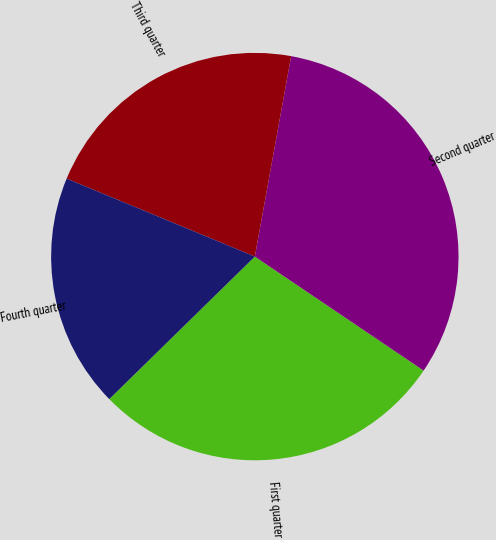Convert chart. <chart><loc_0><loc_0><loc_500><loc_500><pie_chart><fcel>First quarter<fcel>Second quarter<fcel>Third quarter<fcel>Fourth quarter<nl><fcel>28.21%<fcel>31.6%<fcel>21.6%<fcel>18.58%<nl></chart> 